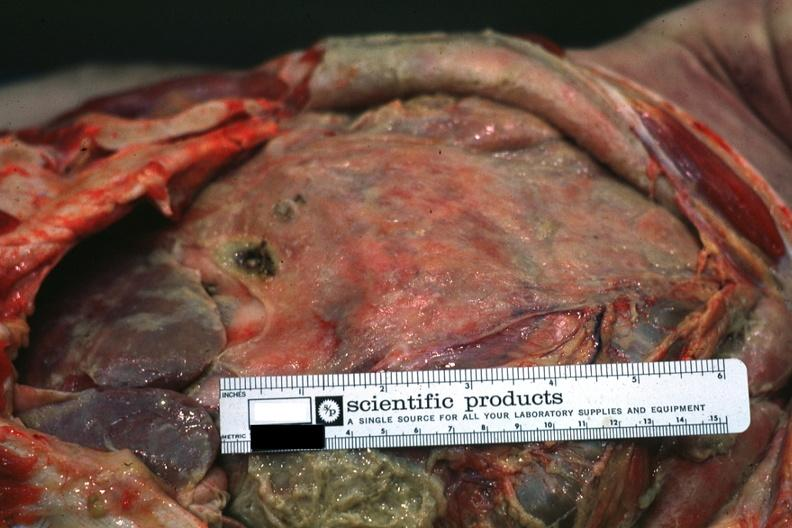what covered by fibrinopurulent membrane due to ruptured peptic ulcer?
Answer the question using a single word or phrase. Intestines 